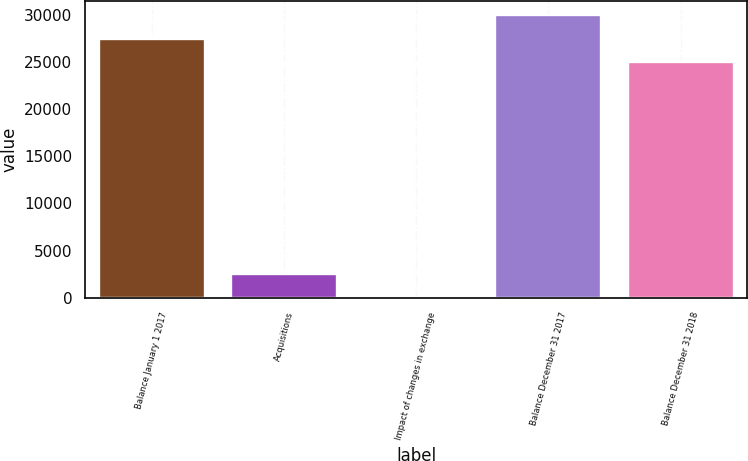<chart> <loc_0><loc_0><loc_500><loc_500><bar_chart><fcel>Balance January 1 2017<fcel>Acquisitions<fcel>Impact of changes in exchange<fcel>Balance December 31 2017<fcel>Balance December 31 2018<nl><fcel>27439.4<fcel>2542.4<fcel>34<fcel>29947.8<fcel>24931<nl></chart> 